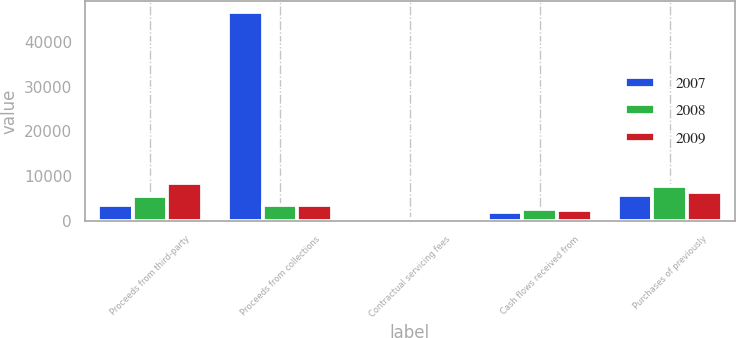<chart> <loc_0><loc_0><loc_500><loc_500><stacked_bar_chart><ecel><fcel>Proceeds from third-party<fcel>Proceeds from collections<fcel>Contractual servicing fees<fcel>Cash flows received from<fcel>Purchases of previously<nl><fcel>2007<fcel>3543<fcel>46753<fcel>490<fcel>1980<fcel>5739<nl><fcel>2008<fcel>5562<fcel>3543<fcel>556<fcel>2777<fcel>7739<nl><fcel>2009<fcel>8434<fcel>3543<fcel>534<fcel>2435<fcel>6474<nl></chart> 